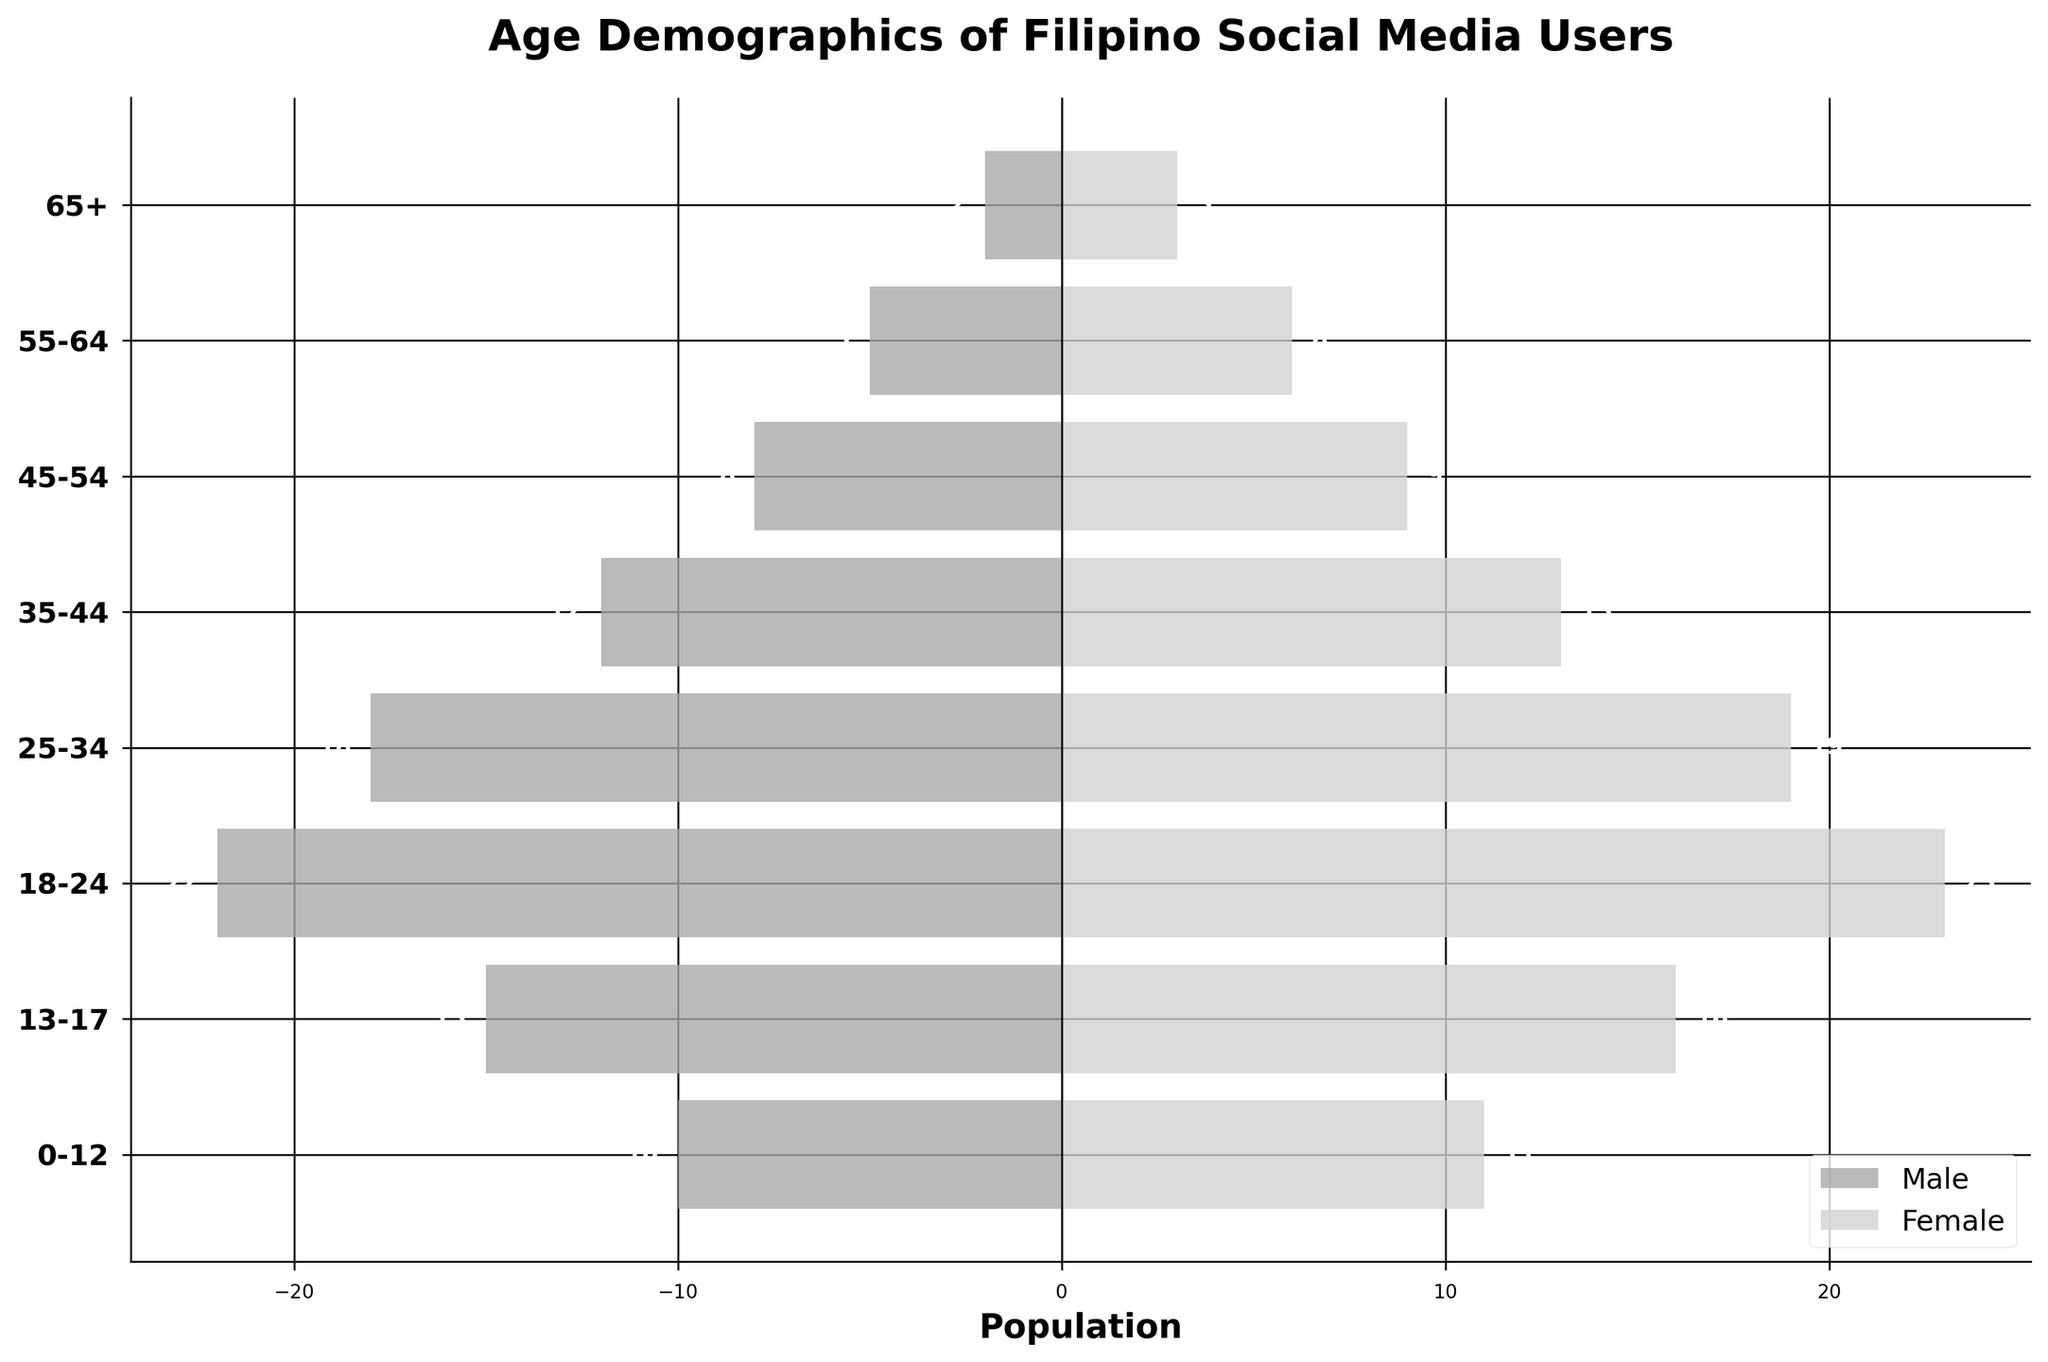what is the title of the figure? The title of a figure is typically placed at the top of the plot. The current figure's title is displayed at the top in bold text.
Answer: Age Demographics of Filipino Social Media Users Which age group has the highest number of male users? By examining the longest bar on the left side of the pyramid, we see that the 18-24 age group has the highest negative value, representing the number of male users.
Answer: 18-24 How many more female users are there in the 25-34 age group compared to male users? The bar representing female users in the 25-34 age group reaches 19, whereas the bar for male users reaches -18. The difference is calculated as 19 - 18.
Answer: 1 What is the total number of social media users in the 45-54 age group? To find the total number of users in this age group, sum the number of male and female users: 8 males + 9 females = 17 users.
Answer: 17 Which age group has the smallest population of social media users? By looking at the length of the bars for each age group, we see that the 65+ age group has the shortest bars, indicating the smallest population.
Answer: 65+ Which age group has a higher percentage of male users compared to female users? By inspecting the bars, the 13-17 age group shows a longer male bar (15) compared to the female bar (16), indicating higher male users.
Answer: 13-17 What is the difference between the number of female users in the 55-64 age group and the 0-12 age group? The number of female users in the 55-64 age group is 6, and in the 0-12 age group, it is 11. The difference is 11 - 6.
Answer: 5 Which gender has more users in the 18-24 age group? By comparing the length of the bars in the 18-24 age group, the female bar (23) is slightly longer than the male bar (22).
Answer: Female How many total users are there in the 35-44 age group? Sum the number of male (12) and female (13) users in the 35-44 age group: 12 + 13.
Answer: 25 